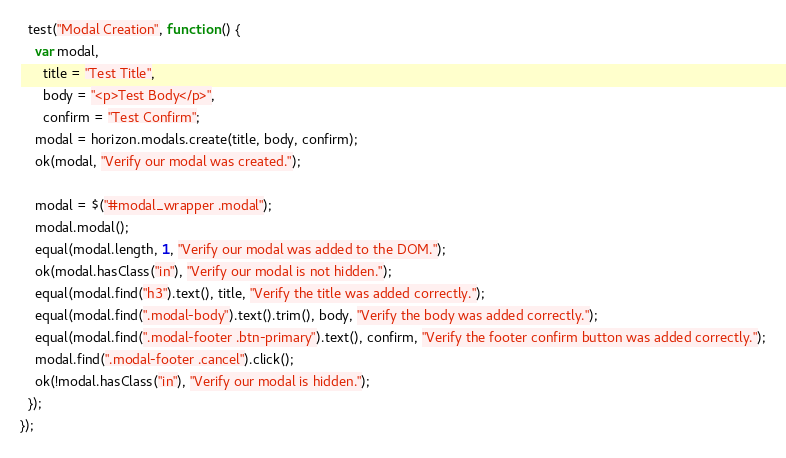Convert code to text. <code><loc_0><loc_0><loc_500><loc_500><_JavaScript_>
  test("Modal Creation", function () {
    var modal,
      title = "Test Title",
      body = "<p>Test Body</p>",
      confirm = "Test Confirm";
    modal = horizon.modals.create(title, body, confirm);
    ok(modal, "Verify our modal was created.");

    modal = $("#modal_wrapper .modal");
    modal.modal();
    equal(modal.length, 1, "Verify our modal was added to the DOM.");
    ok(modal.hasClass("in"), "Verify our modal is not hidden.");
    equal(modal.find("h3").text(), title, "Verify the title was added correctly.");
    equal(modal.find(".modal-body").text().trim(), body, "Verify the body was added correctly.");
    equal(modal.find(".modal-footer .btn-primary").text(), confirm, "Verify the footer confirm button was added correctly.");
    modal.find(".modal-footer .cancel").click();
    ok(!modal.hasClass("in"), "Verify our modal is hidden.");
  });
});
</code> 